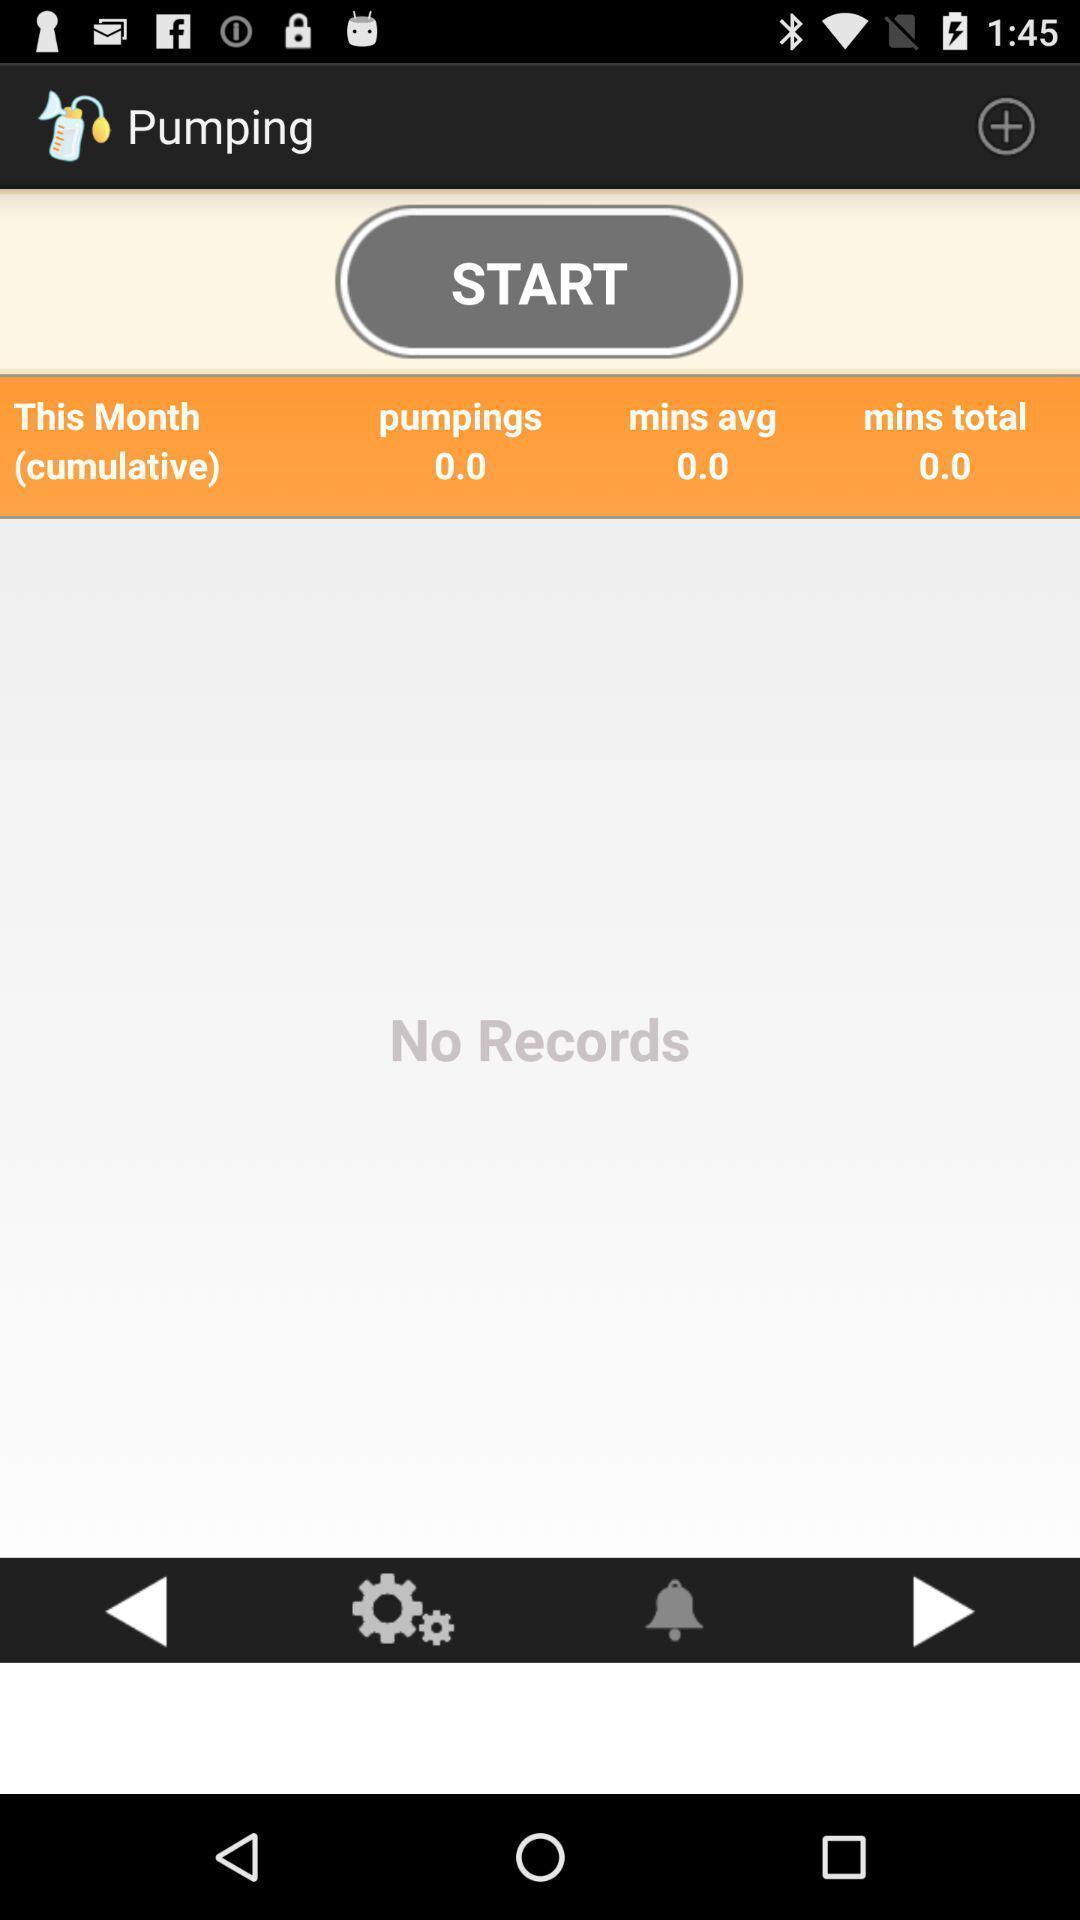Summarize the main components in this picture. Starting page of application in the mobile. 